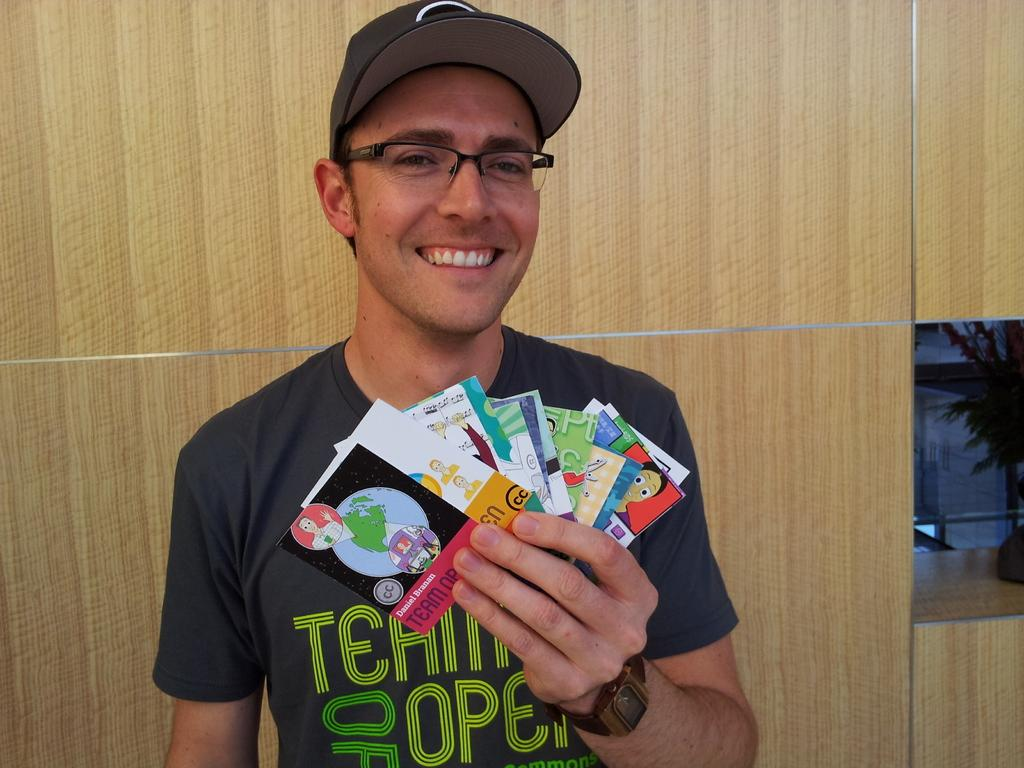What is the main subject of the image? There is a person in the image. What is the person doing in the image? The person is smiling. What is the person holding in their hand? The person is holding cards in their hand. How many times has the person experienced development in the image? There is no information about the person's development in the image, as it only shows them smiling and holding cards. 